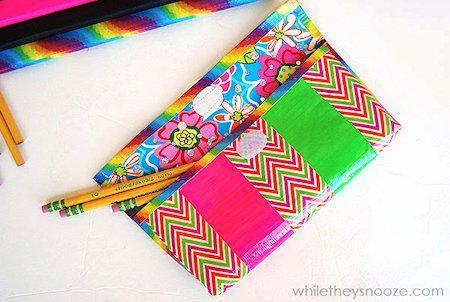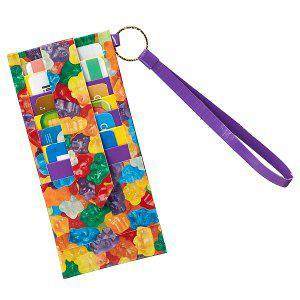The first image is the image on the left, the second image is the image on the right. For the images displayed, is the sentence "In one of the images, three pencils are sticking out of the front pocket on the pencil case." factually correct? Answer yes or no. Yes. 